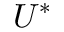<formula> <loc_0><loc_0><loc_500><loc_500>U ^ { * }</formula> 